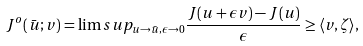<formula> <loc_0><loc_0><loc_500><loc_500>J ^ { o } ( \bar { u } ; v ) = \lim s u p _ { u \rightarrow \bar { u } , \epsilon \rightarrow 0 } \frac { J ( u + \epsilon v ) - J ( u ) } { \epsilon } \geq \langle v , \zeta \rangle ,</formula> 